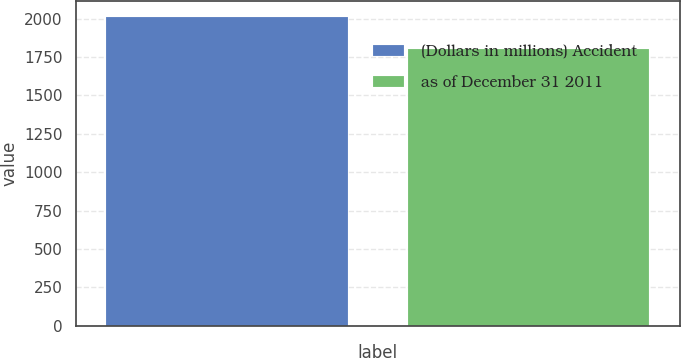<chart> <loc_0><loc_0><loc_500><loc_500><bar_chart><fcel>(Dollars in millions) Accident<fcel>as of December 31 2011<nl><fcel>2011<fcel>1804<nl></chart> 